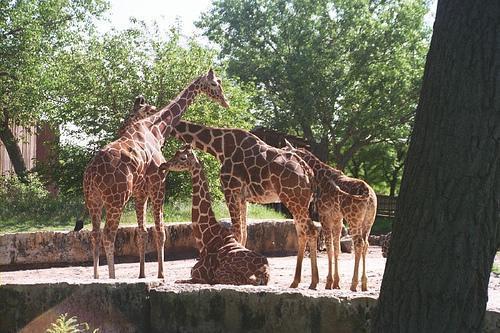How many giraffes are there?
Give a very brief answer. 4. How many giraffes are visible?
Give a very brief answer. 4. How many people are in the photo?
Give a very brief answer. 0. 